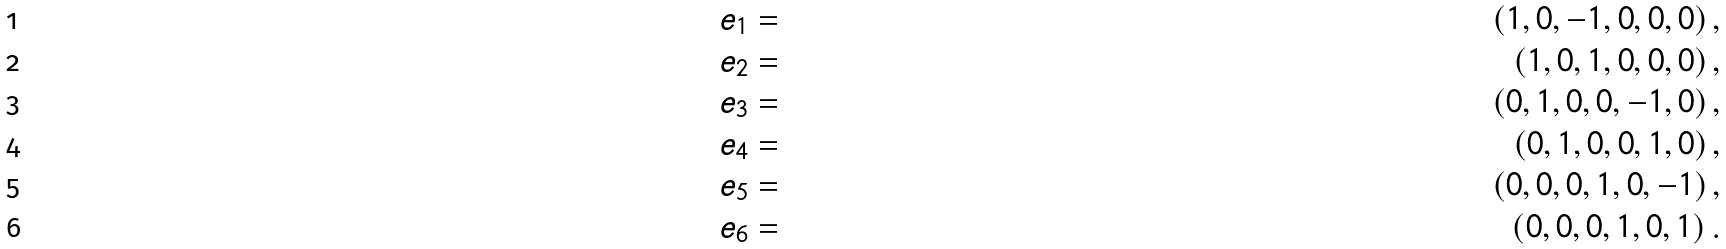Convert formula to latex. <formula><loc_0><loc_0><loc_500><loc_500>e _ { 1 } & = & \left ( 1 , 0 , - 1 , 0 , 0 , 0 \right ) , \\ e _ { 2 } & = & \left ( 1 , 0 , 1 , 0 , 0 , 0 \right ) , \\ e _ { 3 } & = & \left ( 0 , 1 , 0 , 0 , - 1 , 0 \right ) , \\ e _ { 4 } & = & \left ( 0 , 1 , 0 , 0 , 1 , 0 \right ) , \\ e _ { 5 } & = & \left ( 0 , 0 , 0 , 1 , 0 , - 1 \right ) , \\ e _ { 6 } & = & \left ( 0 , 0 , 0 , 1 , 0 , 1 \right ) .</formula> 